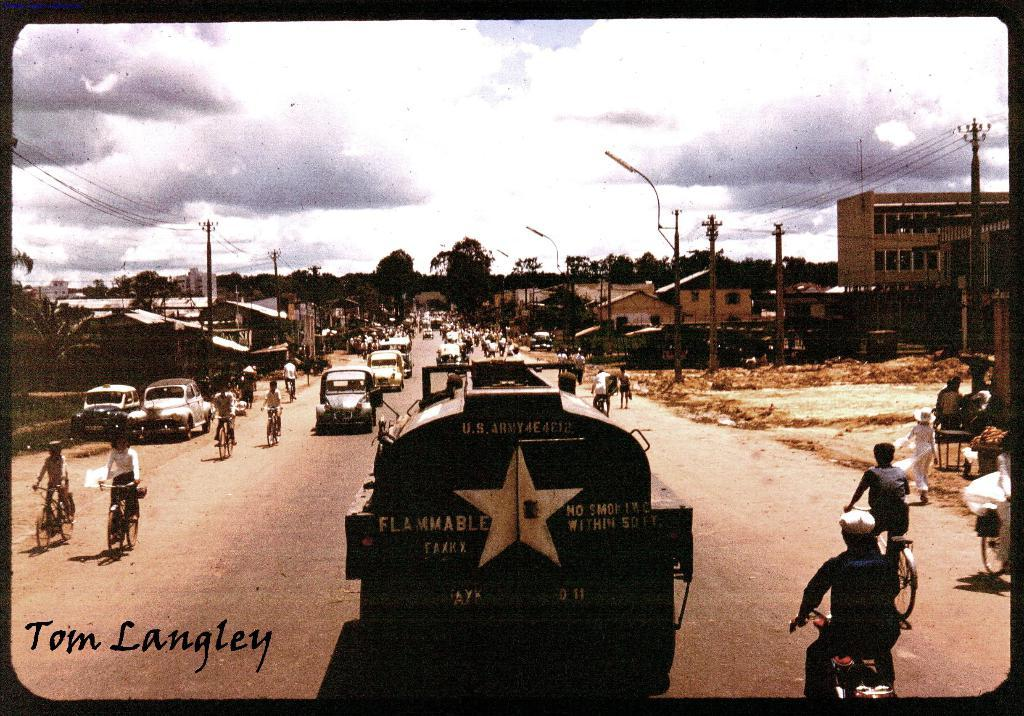<image>
Create a compact narrative representing the image presented. the word tom that is on the bottom left of a photo 